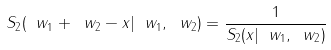<formula> <loc_0><loc_0><loc_500><loc_500>S _ { 2 } ( \ w _ { 1 } + \ w _ { 2 } - x | \ w _ { 1 } , \ w _ { 2 } ) = \frac { 1 } { S _ { 2 } ( x | \ w _ { 1 } , \ w _ { 2 } ) }</formula> 